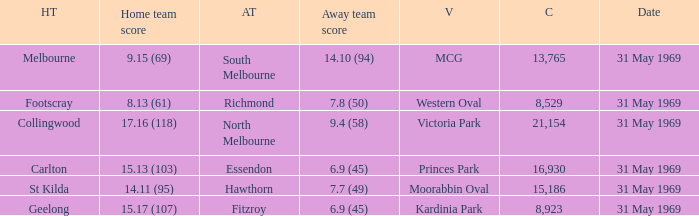Which home team scored 14.11 (95)? St Kilda. 